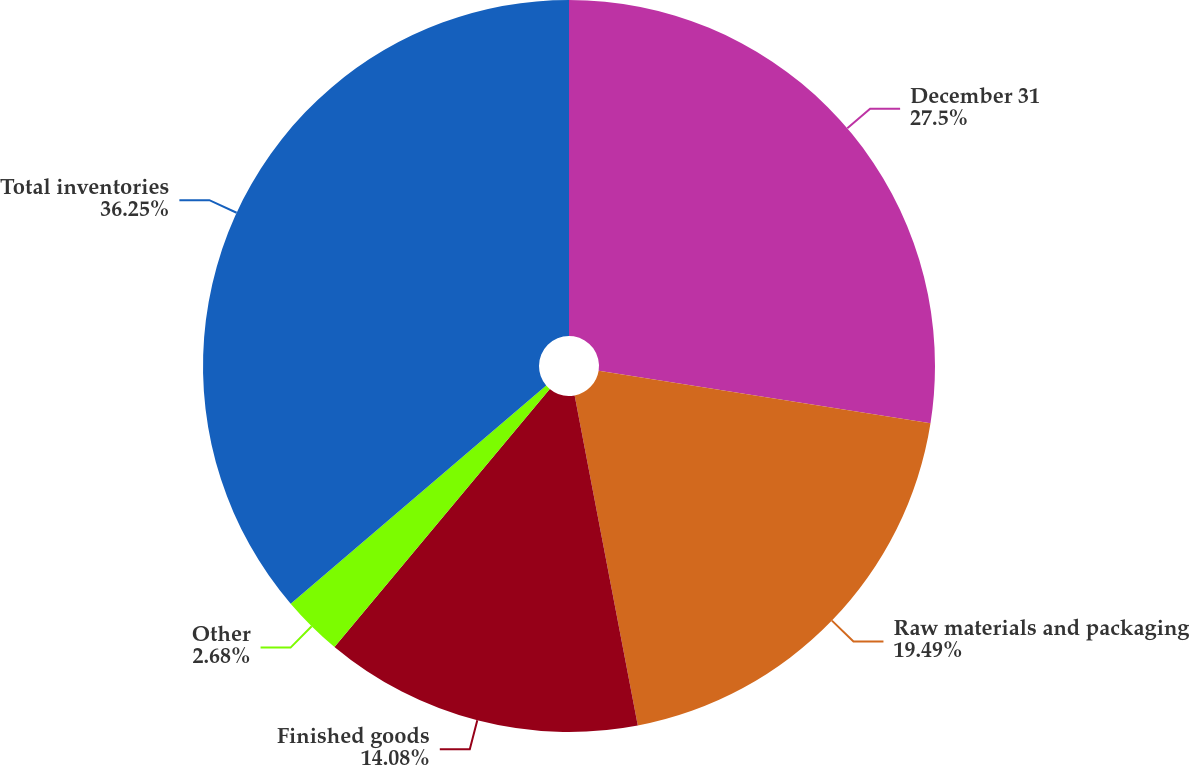Convert chart. <chart><loc_0><loc_0><loc_500><loc_500><pie_chart><fcel>December 31<fcel>Raw materials and packaging<fcel>Finished goods<fcel>Other<fcel>Total inventories<nl><fcel>27.5%<fcel>19.49%<fcel>14.08%<fcel>2.68%<fcel>36.25%<nl></chart> 